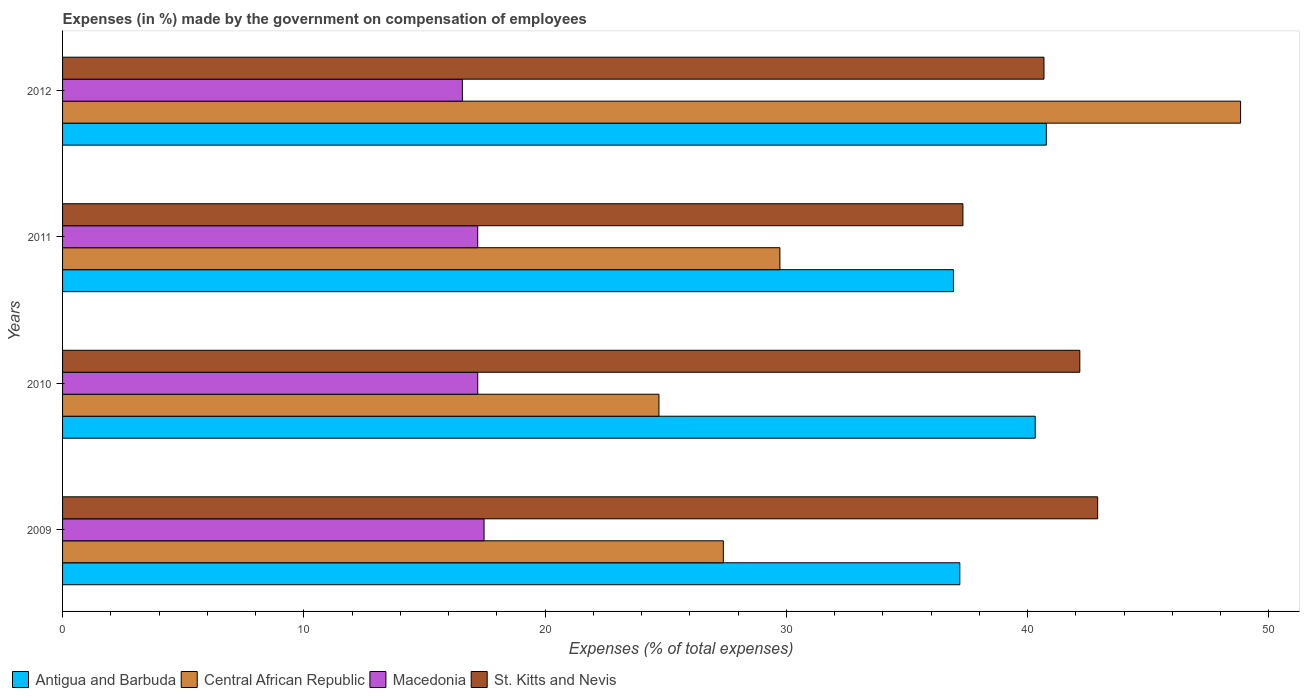How many groups of bars are there?
Give a very brief answer. 4. Are the number of bars per tick equal to the number of legend labels?
Provide a succinct answer. Yes. Are the number of bars on each tick of the Y-axis equal?
Provide a succinct answer. Yes. How many bars are there on the 4th tick from the top?
Your answer should be compact. 4. How many bars are there on the 3rd tick from the bottom?
Your answer should be very brief. 4. In how many cases, is the number of bars for a given year not equal to the number of legend labels?
Offer a very short reply. 0. What is the percentage of expenses made by the government on compensation of employees in Antigua and Barbuda in 2009?
Keep it short and to the point. 37.19. Across all years, what is the maximum percentage of expenses made by the government on compensation of employees in Antigua and Barbuda?
Give a very brief answer. 40.77. Across all years, what is the minimum percentage of expenses made by the government on compensation of employees in St. Kitts and Nevis?
Keep it short and to the point. 37.32. What is the total percentage of expenses made by the government on compensation of employees in St. Kitts and Nevis in the graph?
Provide a succinct answer. 163.06. What is the difference between the percentage of expenses made by the government on compensation of employees in Antigua and Barbuda in 2010 and that in 2012?
Give a very brief answer. -0.46. What is the difference between the percentage of expenses made by the government on compensation of employees in Macedonia in 2011 and the percentage of expenses made by the government on compensation of employees in Antigua and Barbuda in 2012?
Your answer should be compact. -23.57. What is the average percentage of expenses made by the government on compensation of employees in Antigua and Barbuda per year?
Keep it short and to the point. 38.8. In the year 2010, what is the difference between the percentage of expenses made by the government on compensation of employees in St. Kitts and Nevis and percentage of expenses made by the government on compensation of employees in Central African Republic?
Your answer should be very brief. 17.44. What is the ratio of the percentage of expenses made by the government on compensation of employees in Central African Republic in 2010 to that in 2012?
Give a very brief answer. 0.51. Is the difference between the percentage of expenses made by the government on compensation of employees in St. Kitts and Nevis in 2010 and 2011 greater than the difference between the percentage of expenses made by the government on compensation of employees in Central African Republic in 2010 and 2011?
Keep it short and to the point. Yes. What is the difference between the highest and the second highest percentage of expenses made by the government on compensation of employees in St. Kitts and Nevis?
Your answer should be very brief. 0.74. What is the difference between the highest and the lowest percentage of expenses made by the government on compensation of employees in Central African Republic?
Give a very brief answer. 24.11. Is the sum of the percentage of expenses made by the government on compensation of employees in Central African Republic in 2009 and 2012 greater than the maximum percentage of expenses made by the government on compensation of employees in Macedonia across all years?
Your response must be concise. Yes. What does the 2nd bar from the top in 2009 represents?
Offer a very short reply. Macedonia. What does the 2nd bar from the bottom in 2010 represents?
Ensure brevity in your answer.  Central African Republic. Is it the case that in every year, the sum of the percentage of expenses made by the government on compensation of employees in Central African Republic and percentage of expenses made by the government on compensation of employees in Antigua and Barbuda is greater than the percentage of expenses made by the government on compensation of employees in Macedonia?
Provide a short and direct response. Yes. How many bars are there?
Offer a terse response. 16. Are all the bars in the graph horizontal?
Your answer should be compact. Yes. How many years are there in the graph?
Make the answer very short. 4. What is the difference between two consecutive major ticks on the X-axis?
Offer a very short reply. 10. Are the values on the major ticks of X-axis written in scientific E-notation?
Keep it short and to the point. No. Does the graph contain grids?
Provide a short and direct response. No. How many legend labels are there?
Ensure brevity in your answer.  4. What is the title of the graph?
Your response must be concise. Expenses (in %) made by the government on compensation of employees. Does "Iran" appear as one of the legend labels in the graph?
Keep it short and to the point. No. What is the label or title of the X-axis?
Give a very brief answer. Expenses (% of total expenses). What is the label or title of the Y-axis?
Your response must be concise. Years. What is the Expenses (% of total expenses) in Antigua and Barbuda in 2009?
Keep it short and to the point. 37.19. What is the Expenses (% of total expenses) in Central African Republic in 2009?
Provide a short and direct response. 27.39. What is the Expenses (% of total expenses) in Macedonia in 2009?
Give a very brief answer. 17.47. What is the Expenses (% of total expenses) of St. Kitts and Nevis in 2009?
Keep it short and to the point. 42.9. What is the Expenses (% of total expenses) of Antigua and Barbuda in 2010?
Your answer should be very brief. 40.31. What is the Expenses (% of total expenses) in Central African Republic in 2010?
Ensure brevity in your answer.  24.72. What is the Expenses (% of total expenses) in Macedonia in 2010?
Ensure brevity in your answer.  17.21. What is the Expenses (% of total expenses) in St. Kitts and Nevis in 2010?
Ensure brevity in your answer.  42.16. What is the Expenses (% of total expenses) in Antigua and Barbuda in 2011?
Make the answer very short. 36.92. What is the Expenses (% of total expenses) in Central African Republic in 2011?
Make the answer very short. 29.73. What is the Expenses (% of total expenses) in Macedonia in 2011?
Make the answer very short. 17.21. What is the Expenses (% of total expenses) of St. Kitts and Nevis in 2011?
Provide a succinct answer. 37.32. What is the Expenses (% of total expenses) of Antigua and Barbuda in 2012?
Offer a terse response. 40.77. What is the Expenses (% of total expenses) in Central African Republic in 2012?
Make the answer very short. 48.83. What is the Expenses (% of total expenses) in Macedonia in 2012?
Your answer should be very brief. 16.57. What is the Expenses (% of total expenses) of St. Kitts and Nevis in 2012?
Make the answer very short. 40.68. Across all years, what is the maximum Expenses (% of total expenses) of Antigua and Barbuda?
Offer a terse response. 40.77. Across all years, what is the maximum Expenses (% of total expenses) in Central African Republic?
Offer a very short reply. 48.83. Across all years, what is the maximum Expenses (% of total expenses) in Macedonia?
Your answer should be very brief. 17.47. Across all years, what is the maximum Expenses (% of total expenses) of St. Kitts and Nevis?
Keep it short and to the point. 42.9. Across all years, what is the minimum Expenses (% of total expenses) in Antigua and Barbuda?
Keep it short and to the point. 36.92. Across all years, what is the minimum Expenses (% of total expenses) of Central African Republic?
Give a very brief answer. 24.72. Across all years, what is the minimum Expenses (% of total expenses) in Macedonia?
Your answer should be very brief. 16.57. Across all years, what is the minimum Expenses (% of total expenses) in St. Kitts and Nevis?
Your answer should be very brief. 37.32. What is the total Expenses (% of total expenses) in Antigua and Barbuda in the graph?
Give a very brief answer. 155.2. What is the total Expenses (% of total expenses) in Central African Republic in the graph?
Ensure brevity in your answer.  130.66. What is the total Expenses (% of total expenses) in Macedonia in the graph?
Your answer should be compact. 68.45. What is the total Expenses (% of total expenses) of St. Kitts and Nevis in the graph?
Provide a succinct answer. 163.06. What is the difference between the Expenses (% of total expenses) in Antigua and Barbuda in 2009 and that in 2010?
Your answer should be compact. -3.13. What is the difference between the Expenses (% of total expenses) of Central African Republic in 2009 and that in 2010?
Offer a very short reply. 2.67. What is the difference between the Expenses (% of total expenses) in Macedonia in 2009 and that in 2010?
Provide a short and direct response. 0.26. What is the difference between the Expenses (% of total expenses) of St. Kitts and Nevis in 2009 and that in 2010?
Make the answer very short. 0.74. What is the difference between the Expenses (% of total expenses) in Antigua and Barbuda in 2009 and that in 2011?
Give a very brief answer. 0.26. What is the difference between the Expenses (% of total expenses) in Central African Republic in 2009 and that in 2011?
Make the answer very short. -2.34. What is the difference between the Expenses (% of total expenses) of Macedonia in 2009 and that in 2011?
Your answer should be very brief. 0.26. What is the difference between the Expenses (% of total expenses) of St. Kitts and Nevis in 2009 and that in 2011?
Provide a succinct answer. 5.58. What is the difference between the Expenses (% of total expenses) of Antigua and Barbuda in 2009 and that in 2012?
Ensure brevity in your answer.  -3.59. What is the difference between the Expenses (% of total expenses) of Central African Republic in 2009 and that in 2012?
Your answer should be very brief. -21.44. What is the difference between the Expenses (% of total expenses) of Macedonia in 2009 and that in 2012?
Offer a very short reply. 0.9. What is the difference between the Expenses (% of total expenses) in St. Kitts and Nevis in 2009 and that in 2012?
Your answer should be compact. 2.22. What is the difference between the Expenses (% of total expenses) of Antigua and Barbuda in 2010 and that in 2011?
Your answer should be compact. 3.39. What is the difference between the Expenses (% of total expenses) in Central African Republic in 2010 and that in 2011?
Provide a short and direct response. -5.01. What is the difference between the Expenses (% of total expenses) of Macedonia in 2010 and that in 2011?
Your answer should be very brief. 0. What is the difference between the Expenses (% of total expenses) in St. Kitts and Nevis in 2010 and that in 2011?
Your response must be concise. 4.84. What is the difference between the Expenses (% of total expenses) of Antigua and Barbuda in 2010 and that in 2012?
Make the answer very short. -0.46. What is the difference between the Expenses (% of total expenses) of Central African Republic in 2010 and that in 2012?
Your answer should be very brief. -24.11. What is the difference between the Expenses (% of total expenses) in Macedonia in 2010 and that in 2012?
Offer a terse response. 0.64. What is the difference between the Expenses (% of total expenses) of St. Kitts and Nevis in 2010 and that in 2012?
Make the answer very short. 1.48. What is the difference between the Expenses (% of total expenses) of Antigua and Barbuda in 2011 and that in 2012?
Keep it short and to the point. -3.85. What is the difference between the Expenses (% of total expenses) in Central African Republic in 2011 and that in 2012?
Give a very brief answer. -19.09. What is the difference between the Expenses (% of total expenses) of Macedonia in 2011 and that in 2012?
Your response must be concise. 0.64. What is the difference between the Expenses (% of total expenses) of St. Kitts and Nevis in 2011 and that in 2012?
Keep it short and to the point. -3.36. What is the difference between the Expenses (% of total expenses) of Antigua and Barbuda in 2009 and the Expenses (% of total expenses) of Central African Republic in 2010?
Give a very brief answer. 12.47. What is the difference between the Expenses (% of total expenses) in Antigua and Barbuda in 2009 and the Expenses (% of total expenses) in Macedonia in 2010?
Provide a short and direct response. 19.98. What is the difference between the Expenses (% of total expenses) of Antigua and Barbuda in 2009 and the Expenses (% of total expenses) of St. Kitts and Nevis in 2010?
Keep it short and to the point. -4.97. What is the difference between the Expenses (% of total expenses) of Central African Republic in 2009 and the Expenses (% of total expenses) of Macedonia in 2010?
Ensure brevity in your answer.  10.18. What is the difference between the Expenses (% of total expenses) of Central African Republic in 2009 and the Expenses (% of total expenses) of St. Kitts and Nevis in 2010?
Keep it short and to the point. -14.77. What is the difference between the Expenses (% of total expenses) in Macedonia in 2009 and the Expenses (% of total expenses) in St. Kitts and Nevis in 2010?
Offer a very short reply. -24.69. What is the difference between the Expenses (% of total expenses) of Antigua and Barbuda in 2009 and the Expenses (% of total expenses) of Central African Republic in 2011?
Your answer should be very brief. 7.46. What is the difference between the Expenses (% of total expenses) in Antigua and Barbuda in 2009 and the Expenses (% of total expenses) in Macedonia in 2011?
Your answer should be compact. 19.98. What is the difference between the Expenses (% of total expenses) in Antigua and Barbuda in 2009 and the Expenses (% of total expenses) in St. Kitts and Nevis in 2011?
Make the answer very short. -0.13. What is the difference between the Expenses (% of total expenses) in Central African Republic in 2009 and the Expenses (% of total expenses) in Macedonia in 2011?
Ensure brevity in your answer.  10.18. What is the difference between the Expenses (% of total expenses) of Central African Republic in 2009 and the Expenses (% of total expenses) of St. Kitts and Nevis in 2011?
Offer a very short reply. -9.93. What is the difference between the Expenses (% of total expenses) in Macedonia in 2009 and the Expenses (% of total expenses) in St. Kitts and Nevis in 2011?
Give a very brief answer. -19.85. What is the difference between the Expenses (% of total expenses) of Antigua and Barbuda in 2009 and the Expenses (% of total expenses) of Central African Republic in 2012?
Make the answer very short. -11.64. What is the difference between the Expenses (% of total expenses) of Antigua and Barbuda in 2009 and the Expenses (% of total expenses) of Macedonia in 2012?
Offer a terse response. 20.62. What is the difference between the Expenses (% of total expenses) of Antigua and Barbuda in 2009 and the Expenses (% of total expenses) of St. Kitts and Nevis in 2012?
Make the answer very short. -3.49. What is the difference between the Expenses (% of total expenses) of Central African Republic in 2009 and the Expenses (% of total expenses) of Macedonia in 2012?
Ensure brevity in your answer.  10.82. What is the difference between the Expenses (% of total expenses) in Central African Republic in 2009 and the Expenses (% of total expenses) in St. Kitts and Nevis in 2012?
Your answer should be compact. -13.29. What is the difference between the Expenses (% of total expenses) of Macedonia in 2009 and the Expenses (% of total expenses) of St. Kitts and Nevis in 2012?
Ensure brevity in your answer.  -23.21. What is the difference between the Expenses (% of total expenses) of Antigua and Barbuda in 2010 and the Expenses (% of total expenses) of Central African Republic in 2011?
Make the answer very short. 10.58. What is the difference between the Expenses (% of total expenses) of Antigua and Barbuda in 2010 and the Expenses (% of total expenses) of Macedonia in 2011?
Keep it short and to the point. 23.11. What is the difference between the Expenses (% of total expenses) in Antigua and Barbuda in 2010 and the Expenses (% of total expenses) in St. Kitts and Nevis in 2011?
Offer a very short reply. 3. What is the difference between the Expenses (% of total expenses) in Central African Republic in 2010 and the Expenses (% of total expenses) in Macedonia in 2011?
Your answer should be very brief. 7.51. What is the difference between the Expenses (% of total expenses) in Central African Republic in 2010 and the Expenses (% of total expenses) in St. Kitts and Nevis in 2011?
Your answer should be compact. -12.6. What is the difference between the Expenses (% of total expenses) of Macedonia in 2010 and the Expenses (% of total expenses) of St. Kitts and Nevis in 2011?
Keep it short and to the point. -20.11. What is the difference between the Expenses (% of total expenses) in Antigua and Barbuda in 2010 and the Expenses (% of total expenses) in Central African Republic in 2012?
Your response must be concise. -8.51. What is the difference between the Expenses (% of total expenses) in Antigua and Barbuda in 2010 and the Expenses (% of total expenses) in Macedonia in 2012?
Your response must be concise. 23.74. What is the difference between the Expenses (% of total expenses) in Antigua and Barbuda in 2010 and the Expenses (% of total expenses) in St. Kitts and Nevis in 2012?
Offer a terse response. -0.36. What is the difference between the Expenses (% of total expenses) of Central African Republic in 2010 and the Expenses (% of total expenses) of Macedonia in 2012?
Your answer should be compact. 8.15. What is the difference between the Expenses (% of total expenses) of Central African Republic in 2010 and the Expenses (% of total expenses) of St. Kitts and Nevis in 2012?
Provide a short and direct response. -15.96. What is the difference between the Expenses (% of total expenses) in Macedonia in 2010 and the Expenses (% of total expenses) in St. Kitts and Nevis in 2012?
Your answer should be very brief. -23.47. What is the difference between the Expenses (% of total expenses) of Antigua and Barbuda in 2011 and the Expenses (% of total expenses) of Central African Republic in 2012?
Your response must be concise. -11.9. What is the difference between the Expenses (% of total expenses) in Antigua and Barbuda in 2011 and the Expenses (% of total expenses) in Macedonia in 2012?
Offer a very short reply. 20.36. What is the difference between the Expenses (% of total expenses) in Antigua and Barbuda in 2011 and the Expenses (% of total expenses) in St. Kitts and Nevis in 2012?
Your response must be concise. -3.75. What is the difference between the Expenses (% of total expenses) of Central African Republic in 2011 and the Expenses (% of total expenses) of Macedonia in 2012?
Ensure brevity in your answer.  13.16. What is the difference between the Expenses (% of total expenses) of Central African Republic in 2011 and the Expenses (% of total expenses) of St. Kitts and Nevis in 2012?
Your answer should be compact. -10.95. What is the difference between the Expenses (% of total expenses) of Macedonia in 2011 and the Expenses (% of total expenses) of St. Kitts and Nevis in 2012?
Your answer should be compact. -23.47. What is the average Expenses (% of total expenses) in Antigua and Barbuda per year?
Make the answer very short. 38.8. What is the average Expenses (% of total expenses) in Central African Republic per year?
Your answer should be very brief. 32.67. What is the average Expenses (% of total expenses) of Macedonia per year?
Ensure brevity in your answer.  17.11. What is the average Expenses (% of total expenses) in St. Kitts and Nevis per year?
Offer a terse response. 40.76. In the year 2009, what is the difference between the Expenses (% of total expenses) of Antigua and Barbuda and Expenses (% of total expenses) of Central African Republic?
Your answer should be compact. 9.8. In the year 2009, what is the difference between the Expenses (% of total expenses) of Antigua and Barbuda and Expenses (% of total expenses) of Macedonia?
Offer a terse response. 19.72. In the year 2009, what is the difference between the Expenses (% of total expenses) in Antigua and Barbuda and Expenses (% of total expenses) in St. Kitts and Nevis?
Your response must be concise. -5.71. In the year 2009, what is the difference between the Expenses (% of total expenses) in Central African Republic and Expenses (% of total expenses) in Macedonia?
Offer a terse response. 9.92. In the year 2009, what is the difference between the Expenses (% of total expenses) in Central African Republic and Expenses (% of total expenses) in St. Kitts and Nevis?
Give a very brief answer. -15.51. In the year 2009, what is the difference between the Expenses (% of total expenses) of Macedonia and Expenses (% of total expenses) of St. Kitts and Nevis?
Give a very brief answer. -25.43. In the year 2010, what is the difference between the Expenses (% of total expenses) in Antigua and Barbuda and Expenses (% of total expenses) in Central African Republic?
Make the answer very short. 15.6. In the year 2010, what is the difference between the Expenses (% of total expenses) of Antigua and Barbuda and Expenses (% of total expenses) of Macedonia?
Ensure brevity in your answer.  23.11. In the year 2010, what is the difference between the Expenses (% of total expenses) of Antigua and Barbuda and Expenses (% of total expenses) of St. Kitts and Nevis?
Make the answer very short. -1.85. In the year 2010, what is the difference between the Expenses (% of total expenses) of Central African Republic and Expenses (% of total expenses) of Macedonia?
Give a very brief answer. 7.51. In the year 2010, what is the difference between the Expenses (% of total expenses) in Central African Republic and Expenses (% of total expenses) in St. Kitts and Nevis?
Offer a terse response. -17.44. In the year 2010, what is the difference between the Expenses (% of total expenses) in Macedonia and Expenses (% of total expenses) in St. Kitts and Nevis?
Keep it short and to the point. -24.96. In the year 2011, what is the difference between the Expenses (% of total expenses) in Antigua and Barbuda and Expenses (% of total expenses) in Central African Republic?
Your response must be concise. 7.19. In the year 2011, what is the difference between the Expenses (% of total expenses) of Antigua and Barbuda and Expenses (% of total expenses) of Macedonia?
Provide a succinct answer. 19.72. In the year 2011, what is the difference between the Expenses (% of total expenses) in Antigua and Barbuda and Expenses (% of total expenses) in St. Kitts and Nevis?
Keep it short and to the point. -0.39. In the year 2011, what is the difference between the Expenses (% of total expenses) in Central African Republic and Expenses (% of total expenses) in Macedonia?
Your answer should be very brief. 12.53. In the year 2011, what is the difference between the Expenses (% of total expenses) of Central African Republic and Expenses (% of total expenses) of St. Kitts and Nevis?
Ensure brevity in your answer.  -7.59. In the year 2011, what is the difference between the Expenses (% of total expenses) in Macedonia and Expenses (% of total expenses) in St. Kitts and Nevis?
Your answer should be very brief. -20.11. In the year 2012, what is the difference between the Expenses (% of total expenses) of Antigua and Barbuda and Expenses (% of total expenses) of Central African Republic?
Provide a short and direct response. -8.05. In the year 2012, what is the difference between the Expenses (% of total expenses) in Antigua and Barbuda and Expenses (% of total expenses) in Macedonia?
Your answer should be compact. 24.2. In the year 2012, what is the difference between the Expenses (% of total expenses) in Antigua and Barbuda and Expenses (% of total expenses) in St. Kitts and Nevis?
Provide a succinct answer. 0.1. In the year 2012, what is the difference between the Expenses (% of total expenses) of Central African Republic and Expenses (% of total expenses) of Macedonia?
Provide a succinct answer. 32.26. In the year 2012, what is the difference between the Expenses (% of total expenses) of Central African Republic and Expenses (% of total expenses) of St. Kitts and Nevis?
Your answer should be very brief. 8.15. In the year 2012, what is the difference between the Expenses (% of total expenses) in Macedonia and Expenses (% of total expenses) in St. Kitts and Nevis?
Your response must be concise. -24.11. What is the ratio of the Expenses (% of total expenses) in Antigua and Barbuda in 2009 to that in 2010?
Your response must be concise. 0.92. What is the ratio of the Expenses (% of total expenses) of Central African Republic in 2009 to that in 2010?
Offer a terse response. 1.11. What is the ratio of the Expenses (% of total expenses) in Macedonia in 2009 to that in 2010?
Provide a short and direct response. 1.02. What is the ratio of the Expenses (% of total expenses) in St. Kitts and Nevis in 2009 to that in 2010?
Give a very brief answer. 1.02. What is the ratio of the Expenses (% of total expenses) of Antigua and Barbuda in 2009 to that in 2011?
Your response must be concise. 1.01. What is the ratio of the Expenses (% of total expenses) in Central African Republic in 2009 to that in 2011?
Offer a very short reply. 0.92. What is the ratio of the Expenses (% of total expenses) in Macedonia in 2009 to that in 2011?
Provide a short and direct response. 1.02. What is the ratio of the Expenses (% of total expenses) of St. Kitts and Nevis in 2009 to that in 2011?
Ensure brevity in your answer.  1.15. What is the ratio of the Expenses (% of total expenses) of Antigua and Barbuda in 2009 to that in 2012?
Offer a very short reply. 0.91. What is the ratio of the Expenses (% of total expenses) in Central African Republic in 2009 to that in 2012?
Your response must be concise. 0.56. What is the ratio of the Expenses (% of total expenses) in Macedonia in 2009 to that in 2012?
Offer a very short reply. 1.05. What is the ratio of the Expenses (% of total expenses) in St. Kitts and Nevis in 2009 to that in 2012?
Give a very brief answer. 1.05. What is the ratio of the Expenses (% of total expenses) in Antigua and Barbuda in 2010 to that in 2011?
Provide a succinct answer. 1.09. What is the ratio of the Expenses (% of total expenses) in Central African Republic in 2010 to that in 2011?
Offer a very short reply. 0.83. What is the ratio of the Expenses (% of total expenses) in Macedonia in 2010 to that in 2011?
Offer a terse response. 1. What is the ratio of the Expenses (% of total expenses) of St. Kitts and Nevis in 2010 to that in 2011?
Your answer should be compact. 1.13. What is the ratio of the Expenses (% of total expenses) of Antigua and Barbuda in 2010 to that in 2012?
Your answer should be very brief. 0.99. What is the ratio of the Expenses (% of total expenses) in Central African Republic in 2010 to that in 2012?
Ensure brevity in your answer.  0.51. What is the ratio of the Expenses (% of total expenses) in St. Kitts and Nevis in 2010 to that in 2012?
Provide a succinct answer. 1.04. What is the ratio of the Expenses (% of total expenses) in Antigua and Barbuda in 2011 to that in 2012?
Your answer should be very brief. 0.91. What is the ratio of the Expenses (% of total expenses) in Central African Republic in 2011 to that in 2012?
Your answer should be very brief. 0.61. What is the ratio of the Expenses (% of total expenses) of Macedonia in 2011 to that in 2012?
Provide a short and direct response. 1.04. What is the ratio of the Expenses (% of total expenses) in St. Kitts and Nevis in 2011 to that in 2012?
Keep it short and to the point. 0.92. What is the difference between the highest and the second highest Expenses (% of total expenses) of Antigua and Barbuda?
Your answer should be very brief. 0.46. What is the difference between the highest and the second highest Expenses (% of total expenses) of Central African Republic?
Give a very brief answer. 19.09. What is the difference between the highest and the second highest Expenses (% of total expenses) of Macedonia?
Offer a very short reply. 0.26. What is the difference between the highest and the second highest Expenses (% of total expenses) of St. Kitts and Nevis?
Offer a very short reply. 0.74. What is the difference between the highest and the lowest Expenses (% of total expenses) of Antigua and Barbuda?
Keep it short and to the point. 3.85. What is the difference between the highest and the lowest Expenses (% of total expenses) of Central African Republic?
Make the answer very short. 24.11. What is the difference between the highest and the lowest Expenses (% of total expenses) in Macedonia?
Offer a very short reply. 0.9. What is the difference between the highest and the lowest Expenses (% of total expenses) of St. Kitts and Nevis?
Keep it short and to the point. 5.58. 